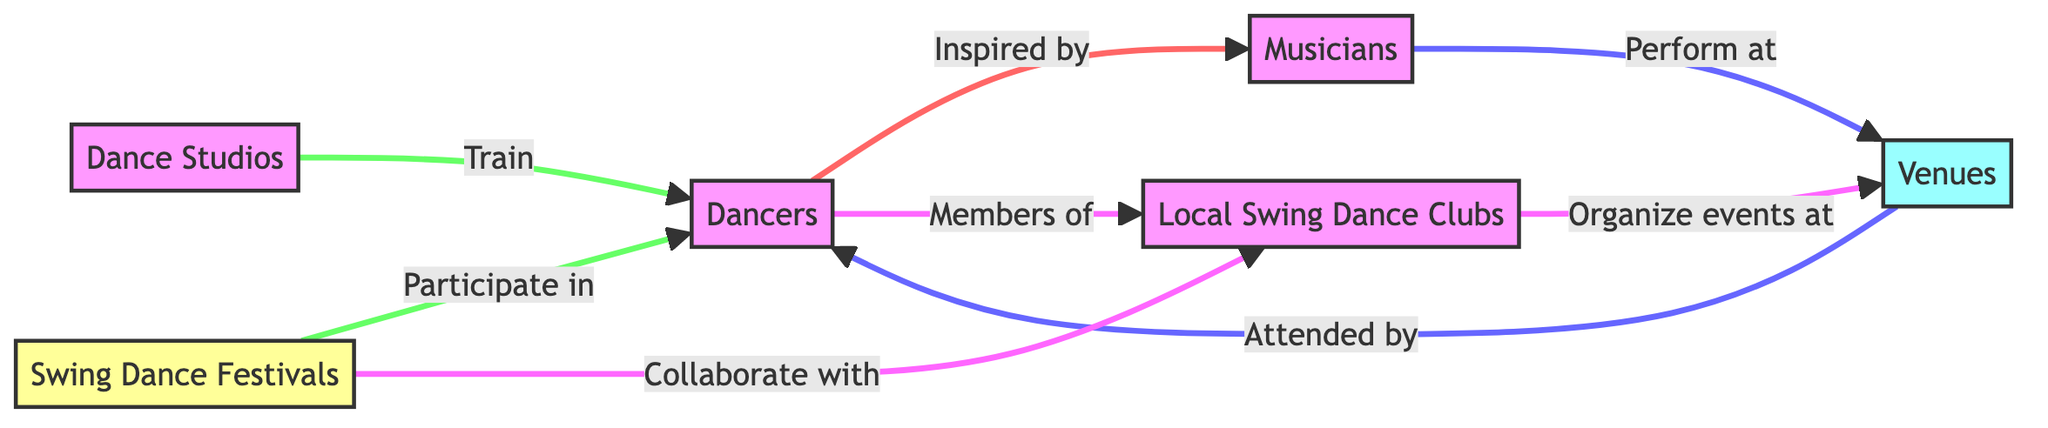What is the total number of nodes in the diagram? The diagram contains six distinct nodes: Dancers, Musicians, Venues, Dance Studios, Swing Dance Festivals, and Local Swing Dance Clubs. Therefore, we count each of these as a unique node to reach a total of six.
Answer: Six Which node is connected to both Dancers and Venues? The Dancers node is connected to the Venues node through a direct relationship where Venues are attended by Dancers. Therefore, Venues is the node that connects both Dancers and Musicians as well.
Answer: Venues What role do Dance Studios play for Dancers? The diagram indicates that Dance Studios provide training for Dancers. This shows that Dance Studios serve a crucial function for the Dancer node in terms of education and skill development.
Answer: Train How many event-related nodes are in the diagram? The diagram includes two event-related nodes: Swing Dance Festivals and Local Swing Dance Clubs. By counting these nodes, we determine that there are two specific nodes classified under event connections in the diagram.
Answer: Two What do Local Swing Dance Clubs organize events at? The diagram shows that Local Swing Dance Clubs organize events at Venues. This means that Local Swing Dance Clubs play a part in planning and executing social gatherings at identified Venues.
Answer: Venues How are Musicians and Dancers connected? Dancers are inspired by Musicians, which indicates an artistic influence. This connection highlights how the energy and rhythm provided by Musicians can motivate and inspire Dancers to express themselves through their art.
Answer: Inspired by Which group collaborates with Local Swing Dance Clubs? Swing Dance Festivals collaborate with Local Swing Dance Clubs as shown in the diagram. This indicates a partnership for carrying out events or activities together between these two types of groups.
Answer: Local Swing Dance Clubs What is the relationship between Local Swing Dance Clubs and Dancers? The relationship established in the diagram shows that Dancers are members of Local Swing Dance Clubs. This illustrates the community ties that exist between Dancers and the organizations they belong to in the Swing dance culture.
Answer: Members of 